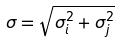<formula> <loc_0><loc_0><loc_500><loc_500>\sigma = \sqrt { \sigma _ { i } ^ { 2 } + \sigma _ { j } ^ { 2 } }</formula> 